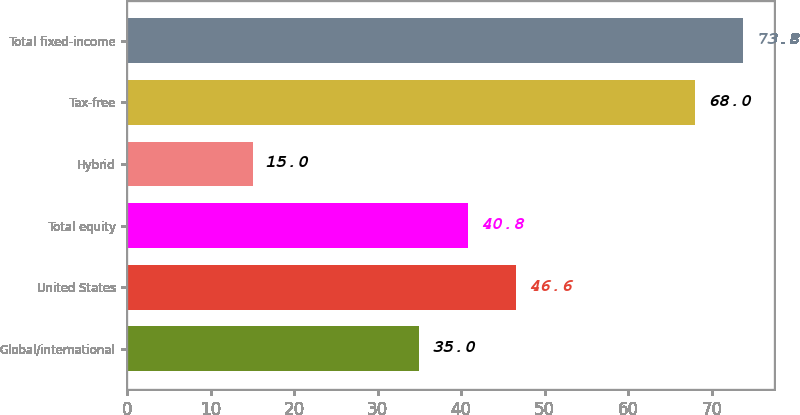Convert chart. <chart><loc_0><loc_0><loc_500><loc_500><bar_chart><fcel>Global/international<fcel>United States<fcel>Total equity<fcel>Hybrid<fcel>Tax-free<fcel>Total fixed-income<nl><fcel>35<fcel>46.6<fcel>40.8<fcel>15<fcel>68<fcel>73.8<nl></chart> 